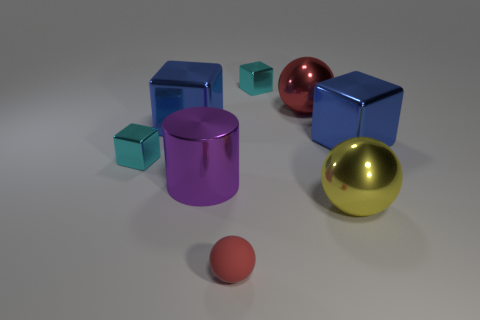Is there anything else that is the same shape as the purple thing?
Provide a short and direct response. No. Are there any tiny shiny blocks that are left of the object behind the large red sphere?
Your answer should be compact. Yes. There is a small shiny thing on the right side of the purple shiny cylinder; is it the same color as the metal ball that is in front of the big purple shiny cylinder?
Give a very brief answer. No. How many big spheres are on the left side of the yellow metallic ball?
Offer a very short reply. 1. How many metal spheres have the same color as the matte thing?
Ensure brevity in your answer.  1. Do the small object that is left of the tiny rubber ball and the small red object have the same material?
Your response must be concise. No. What number of purple things have the same material as the small red ball?
Give a very brief answer. 0. Are there more tiny cubes that are to the right of the large cylinder than large cyan spheres?
Provide a short and direct response. Yes. There is a metallic object that is the same color as the rubber sphere; what size is it?
Offer a terse response. Large. Are there any other shiny things of the same shape as the yellow object?
Provide a succinct answer. Yes. 